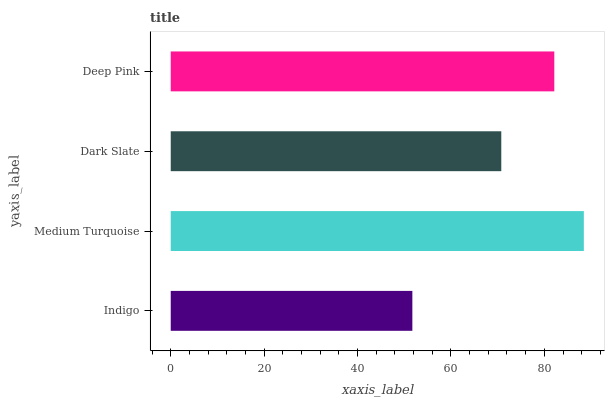Is Indigo the minimum?
Answer yes or no. Yes. Is Medium Turquoise the maximum?
Answer yes or no. Yes. Is Dark Slate the minimum?
Answer yes or no. No. Is Dark Slate the maximum?
Answer yes or no. No. Is Medium Turquoise greater than Dark Slate?
Answer yes or no. Yes. Is Dark Slate less than Medium Turquoise?
Answer yes or no. Yes. Is Dark Slate greater than Medium Turquoise?
Answer yes or no. No. Is Medium Turquoise less than Dark Slate?
Answer yes or no. No. Is Deep Pink the high median?
Answer yes or no. Yes. Is Dark Slate the low median?
Answer yes or no. Yes. Is Dark Slate the high median?
Answer yes or no. No. Is Indigo the low median?
Answer yes or no. No. 